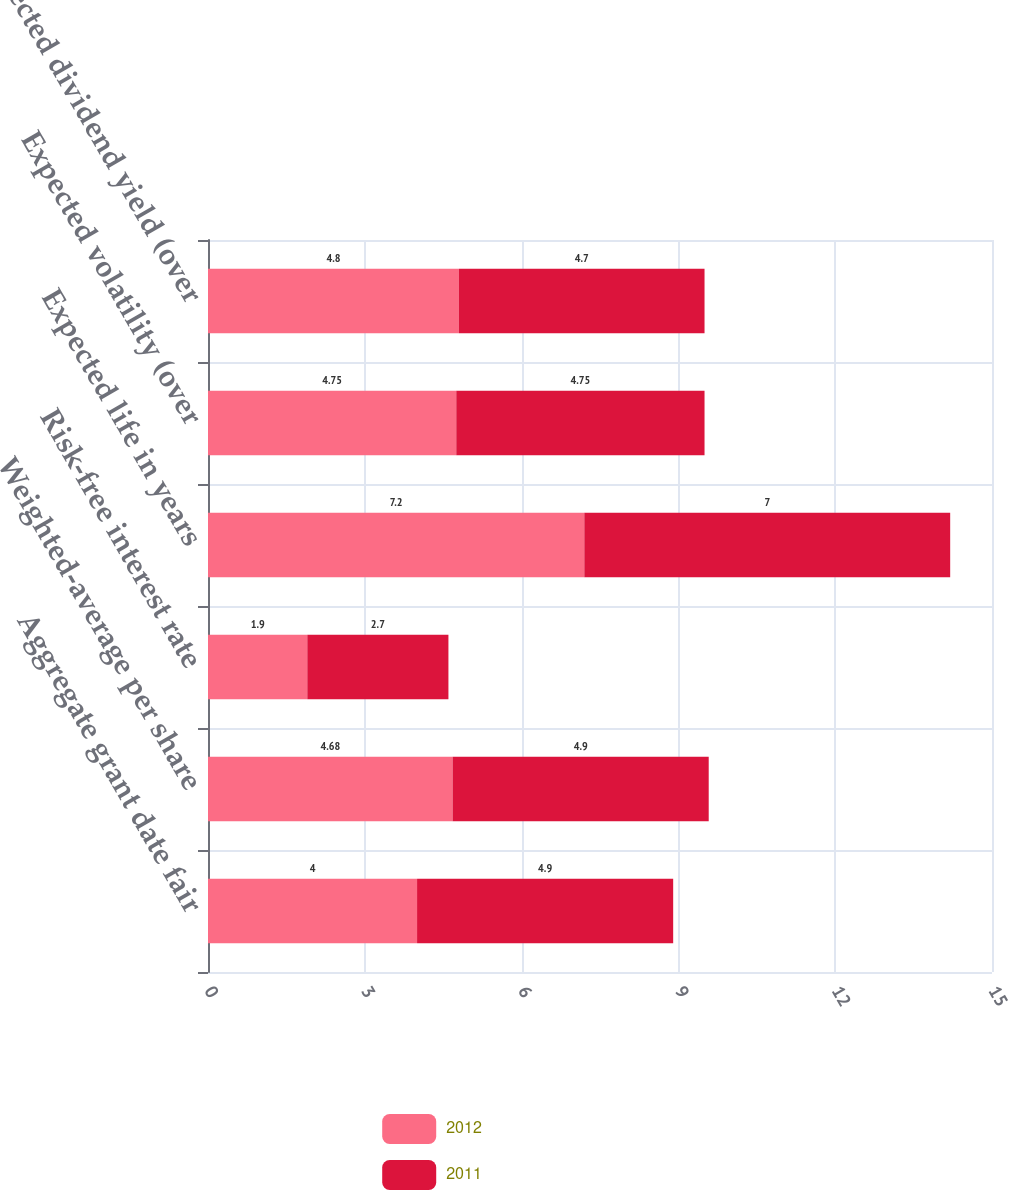<chart> <loc_0><loc_0><loc_500><loc_500><stacked_bar_chart><ecel><fcel>Aggregate grant date fair<fcel>Weighted-average per share<fcel>Risk-free interest rate<fcel>Expected life in years<fcel>Expected volatility (over<fcel>Expected dividend yield (over<nl><fcel>2012<fcel>4<fcel>4.68<fcel>1.9<fcel>7.2<fcel>4.75<fcel>4.8<nl><fcel>2011<fcel>4.9<fcel>4.9<fcel>2.7<fcel>7<fcel>4.75<fcel>4.7<nl></chart> 